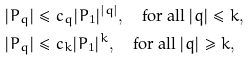Convert formula to latex. <formula><loc_0><loc_0><loc_500><loc_500>& \ | P _ { q } | \leq c _ { q } | P _ { 1 } | ^ { | q | } , \quad \text {for all } | q | \leq k , \\ & \ | P _ { q } | \leq c _ { k } | P _ { 1 } | ^ { k } , \quad \text {for all } | q | \geq k ,</formula> 